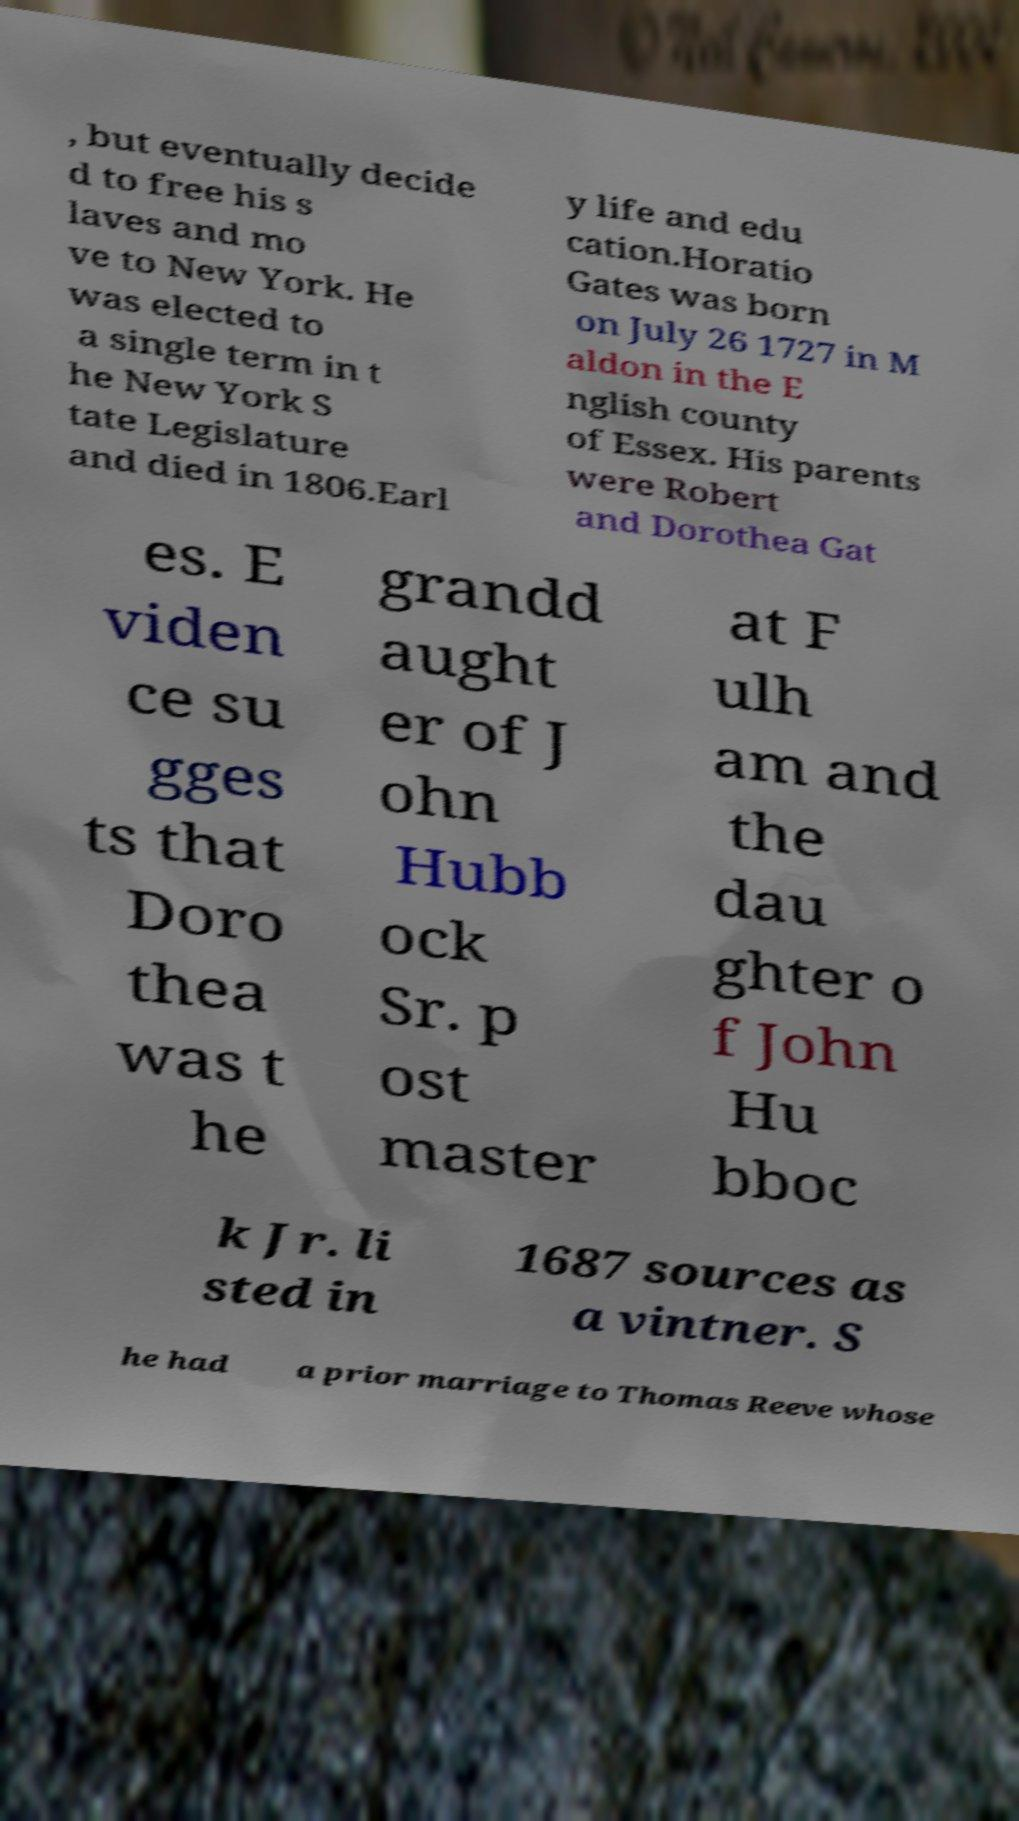Can you read and provide the text displayed in the image?This photo seems to have some interesting text. Can you extract and type it out for me? , but eventually decide d to free his s laves and mo ve to New York. He was elected to a single term in t he New York S tate Legislature and died in 1806.Earl y life and edu cation.Horatio Gates was born on July 26 1727 in M aldon in the E nglish county of Essex. His parents were Robert and Dorothea Gat es. E viden ce su gges ts that Doro thea was t he grandd aught er of J ohn Hubb ock Sr. p ost master at F ulh am and the dau ghter o f John Hu bboc k Jr. li sted in 1687 sources as a vintner. S he had a prior marriage to Thomas Reeve whose 